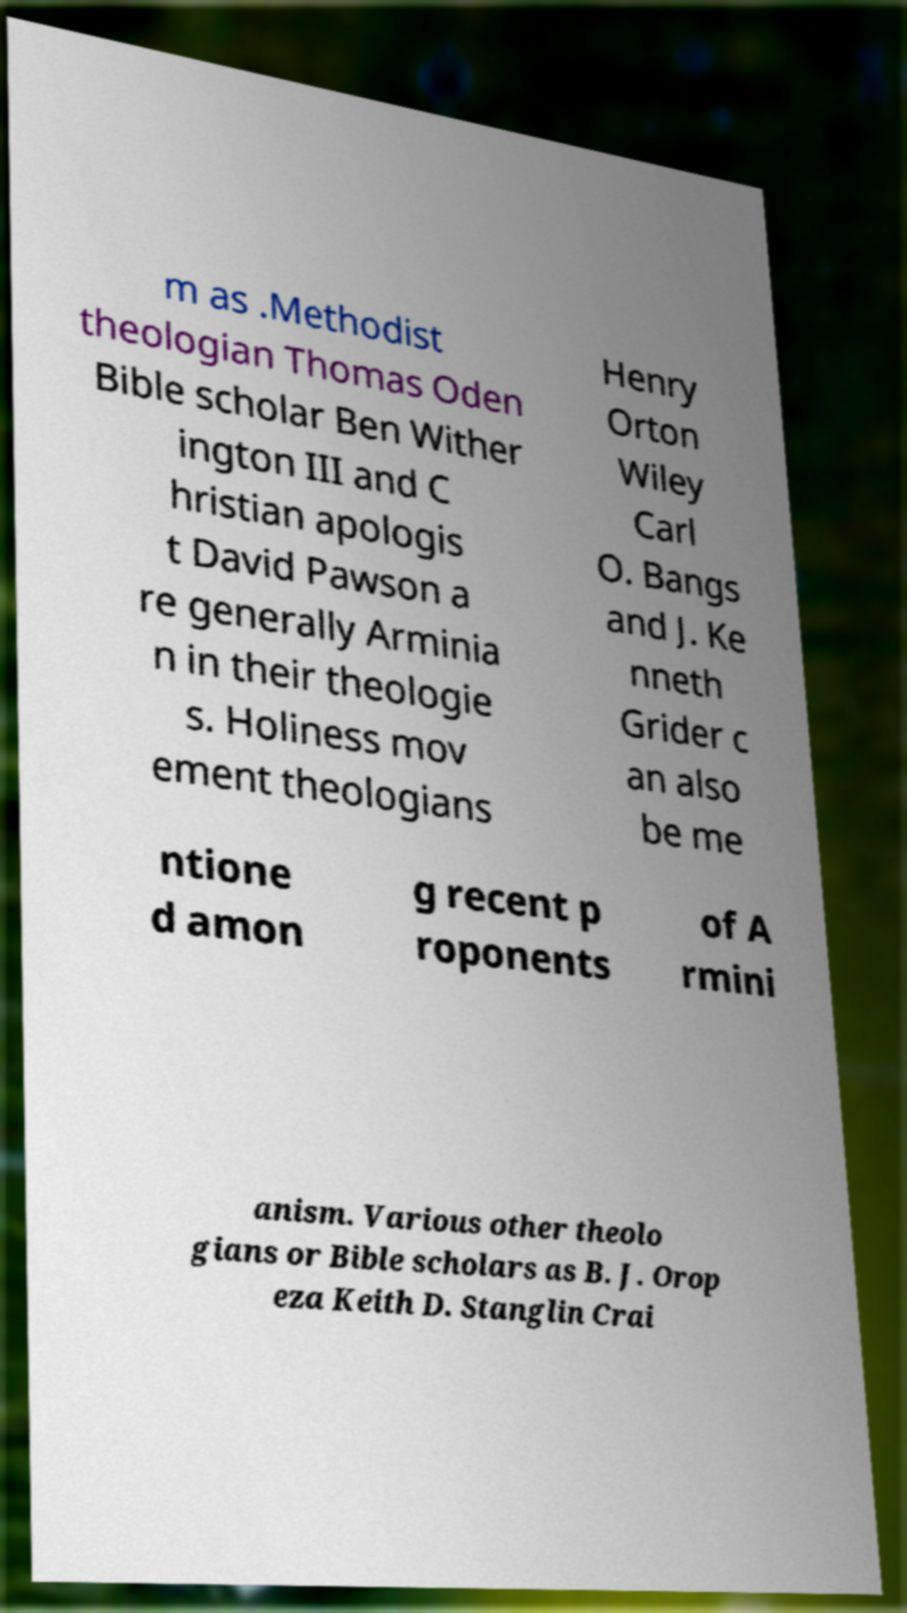There's text embedded in this image that I need extracted. Can you transcribe it verbatim? m as .Methodist theologian Thomas Oden Bible scholar Ben Wither ington III and C hristian apologis t David Pawson a re generally Arminia n in their theologie s. Holiness mov ement theologians Henry Orton Wiley Carl O. Bangs and J. Ke nneth Grider c an also be me ntione d amon g recent p roponents of A rmini anism. Various other theolo gians or Bible scholars as B. J. Orop eza Keith D. Stanglin Crai 